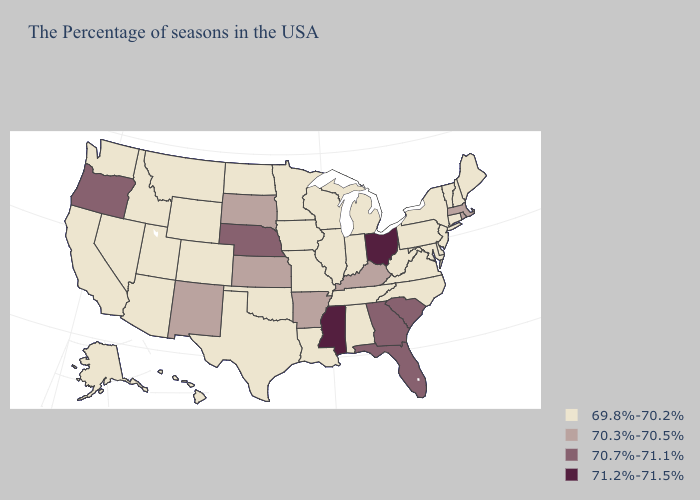What is the value of Vermont?
Give a very brief answer. 69.8%-70.2%. What is the lowest value in the South?
Concise answer only. 69.8%-70.2%. Name the states that have a value in the range 70.7%-71.1%?
Keep it brief. South Carolina, Florida, Georgia, Nebraska, Oregon. What is the lowest value in states that border Alabama?
Give a very brief answer. 69.8%-70.2%. Is the legend a continuous bar?
Write a very short answer. No. What is the highest value in states that border Missouri?
Answer briefly. 70.7%-71.1%. What is the value of Vermont?
Give a very brief answer. 69.8%-70.2%. What is the highest value in the West ?
Write a very short answer. 70.7%-71.1%. Does South Dakota have the highest value in the USA?
Be succinct. No. Name the states that have a value in the range 71.2%-71.5%?
Answer briefly. Ohio, Mississippi. Name the states that have a value in the range 70.7%-71.1%?
Short answer required. South Carolina, Florida, Georgia, Nebraska, Oregon. What is the value of North Carolina?
Give a very brief answer. 69.8%-70.2%. Name the states that have a value in the range 71.2%-71.5%?
Quick response, please. Ohio, Mississippi. Which states hav the highest value in the West?
Concise answer only. Oregon. 